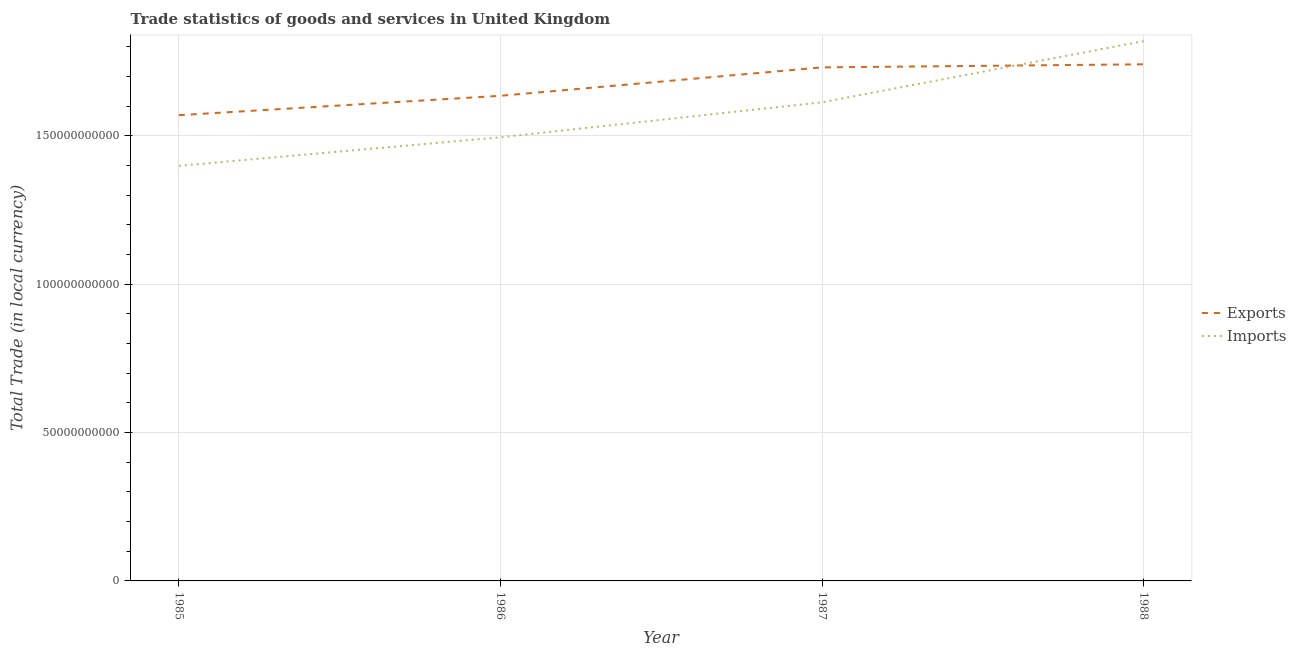How many different coloured lines are there?
Ensure brevity in your answer.  2. Does the line corresponding to export of goods and services intersect with the line corresponding to imports of goods and services?
Offer a terse response. Yes. Is the number of lines equal to the number of legend labels?
Keep it short and to the point. Yes. What is the export of goods and services in 1985?
Give a very brief answer. 1.57e+11. Across all years, what is the maximum imports of goods and services?
Your answer should be very brief. 1.82e+11. Across all years, what is the minimum imports of goods and services?
Your answer should be compact. 1.40e+11. In which year was the export of goods and services maximum?
Provide a succinct answer. 1988. In which year was the imports of goods and services minimum?
Ensure brevity in your answer.  1985. What is the total export of goods and services in the graph?
Your answer should be compact. 6.68e+11. What is the difference between the imports of goods and services in 1986 and that in 1987?
Keep it short and to the point. -1.18e+1. What is the difference between the export of goods and services in 1986 and the imports of goods and services in 1988?
Make the answer very short. -1.84e+1. What is the average export of goods and services per year?
Give a very brief answer. 1.67e+11. In the year 1987, what is the difference between the imports of goods and services and export of goods and services?
Give a very brief answer. -1.18e+1. In how many years, is the imports of goods and services greater than 120000000000 LCU?
Your answer should be very brief. 4. What is the ratio of the imports of goods and services in 1986 to that in 1988?
Make the answer very short. 0.82. What is the difference between the highest and the second highest export of goods and services?
Offer a very short reply. 1.03e+09. What is the difference between the highest and the lowest imports of goods and services?
Your answer should be compact. 4.20e+1. Is the imports of goods and services strictly greater than the export of goods and services over the years?
Provide a succinct answer. No. Is the imports of goods and services strictly less than the export of goods and services over the years?
Give a very brief answer. No. How many lines are there?
Ensure brevity in your answer.  2. How many years are there in the graph?
Your answer should be very brief. 4. Does the graph contain any zero values?
Your response must be concise. No. Does the graph contain grids?
Your answer should be compact. Yes. Where does the legend appear in the graph?
Your response must be concise. Center right. What is the title of the graph?
Offer a terse response. Trade statistics of goods and services in United Kingdom. What is the label or title of the X-axis?
Your answer should be very brief. Year. What is the label or title of the Y-axis?
Provide a succinct answer. Total Trade (in local currency). What is the Total Trade (in local currency) of Exports in 1985?
Provide a short and direct response. 1.57e+11. What is the Total Trade (in local currency) of Imports in 1985?
Ensure brevity in your answer.  1.40e+11. What is the Total Trade (in local currency) in Exports in 1986?
Your answer should be very brief. 1.63e+11. What is the Total Trade (in local currency) of Imports in 1986?
Your answer should be compact. 1.49e+11. What is the Total Trade (in local currency) in Exports in 1987?
Your answer should be very brief. 1.73e+11. What is the Total Trade (in local currency) of Imports in 1987?
Offer a very short reply. 1.61e+11. What is the Total Trade (in local currency) in Exports in 1988?
Offer a terse response. 1.74e+11. What is the Total Trade (in local currency) of Imports in 1988?
Your answer should be very brief. 1.82e+11. Across all years, what is the maximum Total Trade (in local currency) of Exports?
Give a very brief answer. 1.74e+11. Across all years, what is the maximum Total Trade (in local currency) in Imports?
Offer a very short reply. 1.82e+11. Across all years, what is the minimum Total Trade (in local currency) of Exports?
Ensure brevity in your answer.  1.57e+11. Across all years, what is the minimum Total Trade (in local currency) in Imports?
Give a very brief answer. 1.40e+11. What is the total Total Trade (in local currency) of Exports in the graph?
Ensure brevity in your answer.  6.68e+11. What is the total Total Trade (in local currency) in Imports in the graph?
Ensure brevity in your answer.  6.33e+11. What is the difference between the Total Trade (in local currency) of Exports in 1985 and that in 1986?
Provide a succinct answer. -6.53e+09. What is the difference between the Total Trade (in local currency) in Imports in 1985 and that in 1986?
Make the answer very short. -9.61e+09. What is the difference between the Total Trade (in local currency) of Exports in 1985 and that in 1987?
Make the answer very short. -1.61e+1. What is the difference between the Total Trade (in local currency) of Imports in 1985 and that in 1987?
Your answer should be compact. -2.14e+1. What is the difference between the Total Trade (in local currency) in Exports in 1985 and that in 1988?
Your response must be concise. -1.71e+1. What is the difference between the Total Trade (in local currency) of Imports in 1985 and that in 1988?
Your answer should be compact. -4.20e+1. What is the difference between the Total Trade (in local currency) of Exports in 1986 and that in 1987?
Your answer should be compact. -9.58e+09. What is the difference between the Total Trade (in local currency) of Imports in 1986 and that in 1987?
Ensure brevity in your answer.  -1.18e+1. What is the difference between the Total Trade (in local currency) of Exports in 1986 and that in 1988?
Provide a succinct answer. -1.06e+1. What is the difference between the Total Trade (in local currency) of Imports in 1986 and that in 1988?
Give a very brief answer. -3.24e+1. What is the difference between the Total Trade (in local currency) of Exports in 1987 and that in 1988?
Make the answer very short. -1.03e+09. What is the difference between the Total Trade (in local currency) in Imports in 1987 and that in 1988?
Your answer should be very brief. -2.06e+1. What is the difference between the Total Trade (in local currency) of Exports in 1985 and the Total Trade (in local currency) of Imports in 1986?
Make the answer very short. 7.44e+09. What is the difference between the Total Trade (in local currency) in Exports in 1985 and the Total Trade (in local currency) in Imports in 1987?
Your answer should be compact. -4.35e+09. What is the difference between the Total Trade (in local currency) of Exports in 1985 and the Total Trade (in local currency) of Imports in 1988?
Provide a succinct answer. -2.50e+1. What is the difference between the Total Trade (in local currency) in Exports in 1986 and the Total Trade (in local currency) in Imports in 1987?
Offer a terse response. 2.19e+09. What is the difference between the Total Trade (in local currency) of Exports in 1986 and the Total Trade (in local currency) of Imports in 1988?
Provide a succinct answer. -1.84e+1. What is the difference between the Total Trade (in local currency) in Exports in 1987 and the Total Trade (in local currency) in Imports in 1988?
Make the answer very short. -8.85e+09. What is the average Total Trade (in local currency) in Exports per year?
Offer a terse response. 1.67e+11. What is the average Total Trade (in local currency) in Imports per year?
Ensure brevity in your answer.  1.58e+11. In the year 1985, what is the difference between the Total Trade (in local currency) in Exports and Total Trade (in local currency) in Imports?
Provide a short and direct response. 1.71e+1. In the year 1986, what is the difference between the Total Trade (in local currency) of Exports and Total Trade (in local currency) of Imports?
Keep it short and to the point. 1.40e+1. In the year 1987, what is the difference between the Total Trade (in local currency) of Exports and Total Trade (in local currency) of Imports?
Provide a succinct answer. 1.18e+1. In the year 1988, what is the difference between the Total Trade (in local currency) in Exports and Total Trade (in local currency) in Imports?
Your response must be concise. -7.82e+09. What is the ratio of the Total Trade (in local currency) in Exports in 1985 to that in 1986?
Provide a short and direct response. 0.96. What is the ratio of the Total Trade (in local currency) of Imports in 1985 to that in 1986?
Your answer should be compact. 0.94. What is the ratio of the Total Trade (in local currency) in Exports in 1985 to that in 1987?
Ensure brevity in your answer.  0.91. What is the ratio of the Total Trade (in local currency) in Imports in 1985 to that in 1987?
Your response must be concise. 0.87. What is the ratio of the Total Trade (in local currency) of Exports in 1985 to that in 1988?
Offer a very short reply. 0.9. What is the ratio of the Total Trade (in local currency) of Imports in 1985 to that in 1988?
Offer a very short reply. 0.77. What is the ratio of the Total Trade (in local currency) of Exports in 1986 to that in 1987?
Provide a succinct answer. 0.94. What is the ratio of the Total Trade (in local currency) of Imports in 1986 to that in 1987?
Your answer should be compact. 0.93. What is the ratio of the Total Trade (in local currency) in Exports in 1986 to that in 1988?
Offer a very short reply. 0.94. What is the ratio of the Total Trade (in local currency) in Imports in 1986 to that in 1988?
Make the answer very short. 0.82. What is the ratio of the Total Trade (in local currency) in Exports in 1987 to that in 1988?
Offer a terse response. 0.99. What is the ratio of the Total Trade (in local currency) of Imports in 1987 to that in 1988?
Offer a very short reply. 0.89. What is the difference between the highest and the second highest Total Trade (in local currency) in Exports?
Your response must be concise. 1.03e+09. What is the difference between the highest and the second highest Total Trade (in local currency) in Imports?
Make the answer very short. 2.06e+1. What is the difference between the highest and the lowest Total Trade (in local currency) in Exports?
Offer a terse response. 1.71e+1. What is the difference between the highest and the lowest Total Trade (in local currency) in Imports?
Offer a terse response. 4.20e+1. 